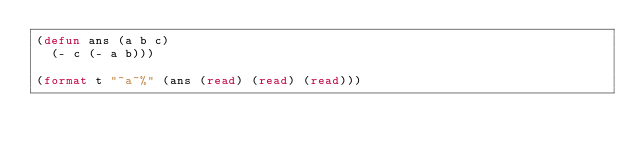<code> <loc_0><loc_0><loc_500><loc_500><_Lisp_>(defun ans (a b c)
  (- c (- a b)))

(format t "~a~%" (ans (read) (read) (read)))</code> 